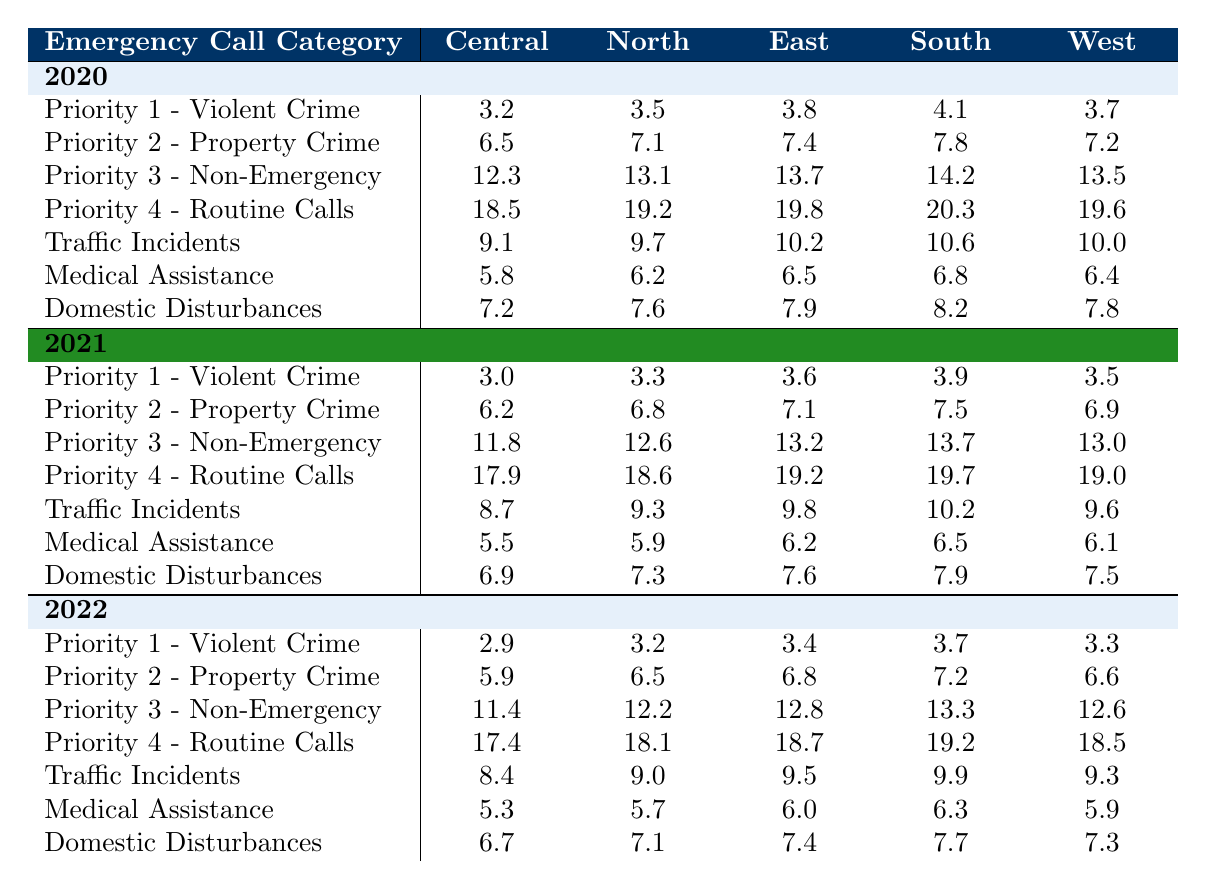What was the response time for Priority 1 - Violent Crime in Central Precinct for the year 2022? The table shows that for Priority 1 - Violent Crime in Central Precinct, the response time in 2022 is 2.9 minutes as seen in the relevant row and column.
Answer: 2.9 Which precinct had the highest response time for Traffic Incidents in 2020? In the 2020 row under Traffic Incidents, the response times for each precinct are: Central 9.1, North 9.7, East 10.2, South 10.6, and West 10.0. South Precinct has the highest time at 10.6 minutes.
Answer: South Precinct What is the average response time for Medical Assistance across all precincts in 2021? The response times for Medical Assistance in 2021 are: Central 5.5, North 5.9, East 6.2, South 6.5, and West 6.1. The sum of these values is 29.2, and dividing by 5 gives an average of 5.84.
Answer: 5.84 Is the response time for Priority 2 - Property Crime decreasing from 2020 to 2022 in the East Precinct? In the East Precinct, the response times for Priority 2 - Property Crime are 7.4 in 2020, 7.1 in 2021, and 6.8 in 2022. Since 7.4 > 7.1 > 6.8, the response time is indeed decreasing.
Answer: Yes Which precinct had the most significant reduction in response time for Domestic Disturbances from 2020 to 2022? In 2020, the response times for Domestic Disturbances were: Central 7.2, North 7.6, East 7.9, South 8.2, and West 7.8. In 2022, they are Central 6.7, North 7.1, East 7.4, South 7.7, and West 7.3. The reductions are Central -0.5, North -0.5, East -0.5, South -0.5, and West -0.5. Therefore, all precincts had the same reduction.
Answer: All had the same reduction Which emergency call category had the longest average response time across all precincts in 2021? In 2021 the response times for each category are: Priority 1 - Violent Crime: 3.5, Priority 2 - Property Crime: 6.9, Priority 3 - Non-Emergency: 13.0, Priority 4 - Routine Calls: 19.0, Traffic Incidents: 9.6, Medical Assistance: 6.1, Domestic Disturbances: 7.5. The highest average response time is for Priority 4 - Routine Calls at 19.0 minutes.
Answer: Priority 4 - Routine Calls What was the difference in response times for Priority 3 - Non-Emergency between 2020 and 2022 in the South Precinct? In the South Precinct, Priority 3 - Non-Emergency response times are 14.2 in 2020 and 13.3 in 2022. The difference is 14.2 - 13.3 = 0.9.
Answer: 0.9 What percentage increase in response time for Priority 2 - Property Crime did the East Precinct see from 2020 to 2021? The response times in East Precinct are 7.4 in 2020 and 7.1 in 2021. The percentage change is ((7.1 - 7.4) / 7.4) * 100 = -4.05%. This indicates a decrease rather than an increase.
Answer: No increase Which call category had the least response time in 2022 across all precincts? The minimum response time across all precincts for 2022 shows that for Priority 1 - Violent Crime the times are 2.9 (Central), 3.2 (North), 3.4 (East), 3.7 (South), and 3.3 (West). The lowest is 2.9.
Answer: Priority 1 - Violent Crime 